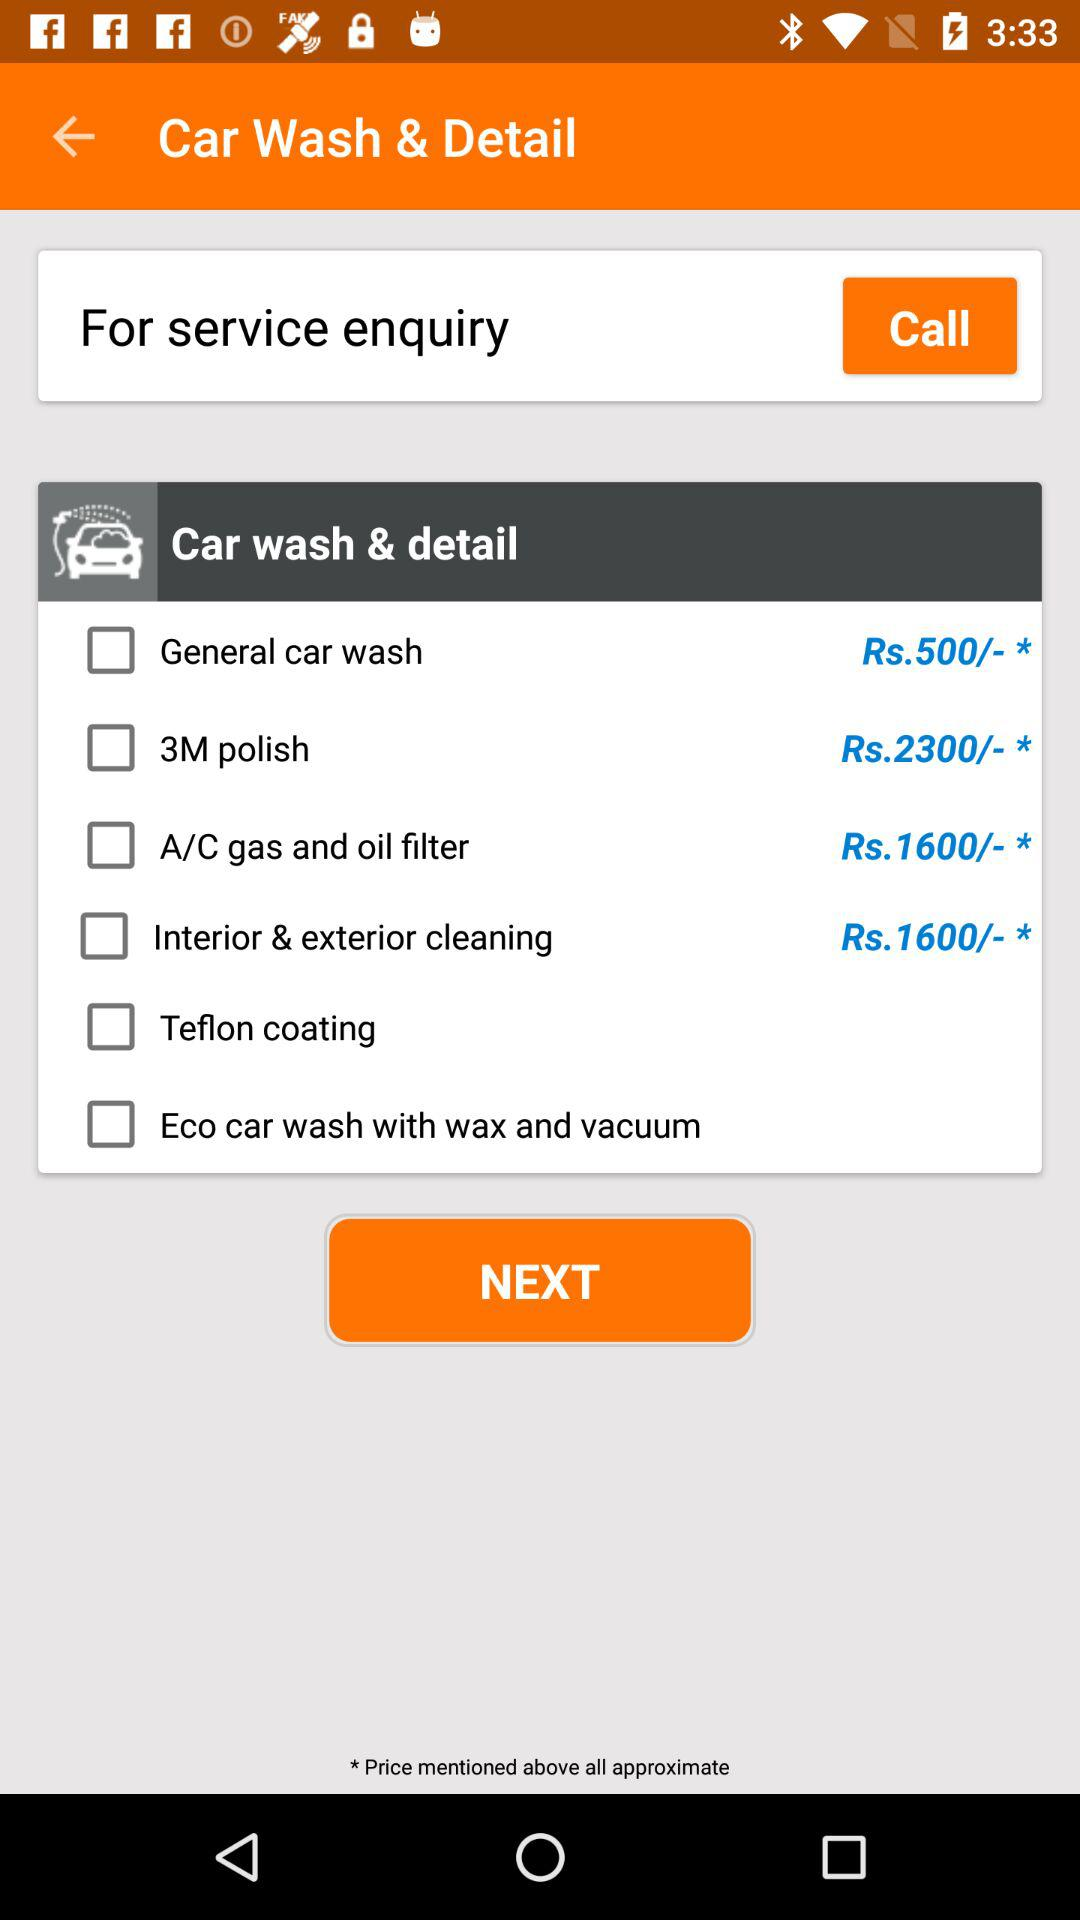What is the cost of interior & exterior cleaning? The cost of interior & exterior cleaning is Rs. 1600. 